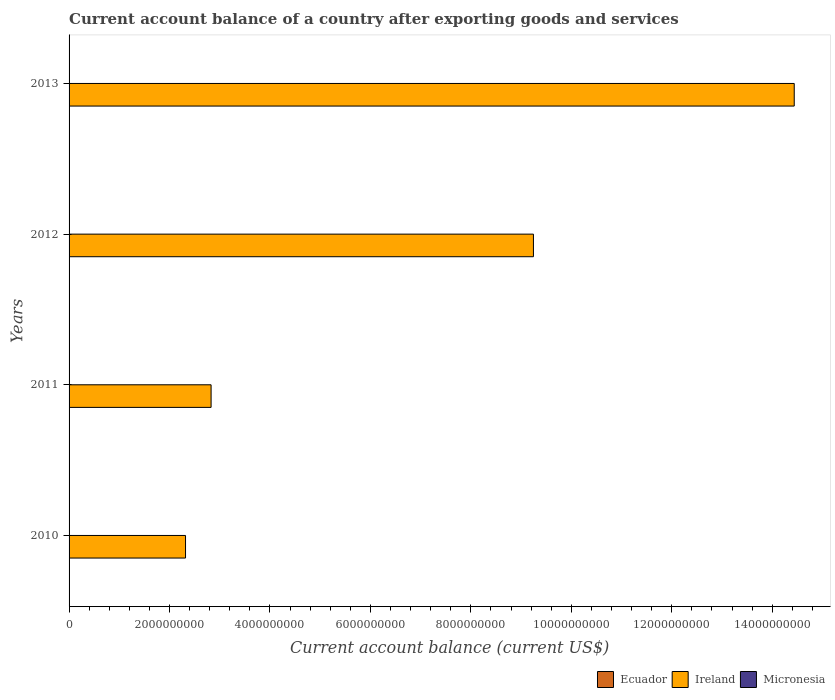Are the number of bars per tick equal to the number of legend labels?
Your answer should be very brief. No. In how many cases, is the number of bars for a given year not equal to the number of legend labels?
Make the answer very short. 4. Across all years, what is the maximum account balance in Ireland?
Give a very brief answer. 1.44e+1. Across all years, what is the minimum account balance in Micronesia?
Your answer should be compact. 0. In which year was the account balance in Ireland maximum?
Your response must be concise. 2013. What is the difference between the account balance in Ireland in 2011 and that in 2013?
Give a very brief answer. -1.16e+1. What is the difference between the account balance in Ecuador in 2011 and the account balance in Ireland in 2013?
Provide a short and direct response. -1.44e+1. What is the ratio of the account balance in Ireland in 2011 to that in 2013?
Your answer should be very brief. 0.2. What is the difference between the highest and the second highest account balance in Ireland?
Provide a succinct answer. 5.19e+09. What is the difference between the highest and the lowest account balance in Ireland?
Offer a very short reply. 1.21e+1. In how many years, is the account balance in Ireland greater than the average account balance in Ireland taken over all years?
Ensure brevity in your answer.  2. Is it the case that in every year, the sum of the account balance in Ireland and account balance in Ecuador is greater than the account balance in Micronesia?
Offer a terse response. Yes. How many bars are there?
Your response must be concise. 4. How many years are there in the graph?
Make the answer very short. 4. Does the graph contain any zero values?
Your answer should be very brief. Yes. Where does the legend appear in the graph?
Offer a very short reply. Bottom right. How many legend labels are there?
Your answer should be compact. 3. How are the legend labels stacked?
Your answer should be very brief. Horizontal. What is the title of the graph?
Keep it short and to the point. Current account balance of a country after exporting goods and services. Does "Bermuda" appear as one of the legend labels in the graph?
Keep it short and to the point. No. What is the label or title of the X-axis?
Your answer should be very brief. Current account balance (current US$). What is the Current account balance (current US$) of Ecuador in 2010?
Offer a terse response. 0. What is the Current account balance (current US$) of Ireland in 2010?
Your response must be concise. 2.32e+09. What is the Current account balance (current US$) in Micronesia in 2010?
Keep it short and to the point. 0. What is the Current account balance (current US$) in Ecuador in 2011?
Your response must be concise. 0. What is the Current account balance (current US$) in Ireland in 2011?
Offer a terse response. 2.83e+09. What is the Current account balance (current US$) in Micronesia in 2011?
Your answer should be very brief. 0. What is the Current account balance (current US$) in Ecuador in 2012?
Provide a short and direct response. 0. What is the Current account balance (current US$) of Ireland in 2012?
Ensure brevity in your answer.  9.25e+09. What is the Current account balance (current US$) of Ireland in 2013?
Keep it short and to the point. 1.44e+1. Across all years, what is the maximum Current account balance (current US$) of Ireland?
Offer a very short reply. 1.44e+1. Across all years, what is the minimum Current account balance (current US$) of Ireland?
Offer a terse response. 2.32e+09. What is the total Current account balance (current US$) of Ecuador in the graph?
Offer a terse response. 0. What is the total Current account balance (current US$) of Ireland in the graph?
Keep it short and to the point. 2.88e+1. What is the total Current account balance (current US$) of Micronesia in the graph?
Provide a short and direct response. 0. What is the difference between the Current account balance (current US$) of Ireland in 2010 and that in 2011?
Make the answer very short. -5.09e+08. What is the difference between the Current account balance (current US$) in Ireland in 2010 and that in 2012?
Give a very brief answer. -6.93e+09. What is the difference between the Current account balance (current US$) in Ireland in 2010 and that in 2013?
Provide a succinct answer. -1.21e+1. What is the difference between the Current account balance (current US$) in Ireland in 2011 and that in 2012?
Offer a very short reply. -6.42e+09. What is the difference between the Current account balance (current US$) of Ireland in 2011 and that in 2013?
Your answer should be compact. -1.16e+1. What is the difference between the Current account balance (current US$) in Ireland in 2012 and that in 2013?
Your response must be concise. -5.19e+09. What is the average Current account balance (current US$) of Ecuador per year?
Give a very brief answer. 0. What is the average Current account balance (current US$) of Ireland per year?
Your answer should be very brief. 7.21e+09. What is the ratio of the Current account balance (current US$) in Ireland in 2010 to that in 2011?
Offer a terse response. 0.82. What is the ratio of the Current account balance (current US$) of Ireland in 2010 to that in 2012?
Offer a terse response. 0.25. What is the ratio of the Current account balance (current US$) of Ireland in 2010 to that in 2013?
Give a very brief answer. 0.16. What is the ratio of the Current account balance (current US$) in Ireland in 2011 to that in 2012?
Your response must be concise. 0.31. What is the ratio of the Current account balance (current US$) in Ireland in 2011 to that in 2013?
Ensure brevity in your answer.  0.2. What is the ratio of the Current account balance (current US$) of Ireland in 2012 to that in 2013?
Offer a very short reply. 0.64. What is the difference between the highest and the second highest Current account balance (current US$) of Ireland?
Keep it short and to the point. 5.19e+09. What is the difference between the highest and the lowest Current account balance (current US$) of Ireland?
Provide a succinct answer. 1.21e+1. 